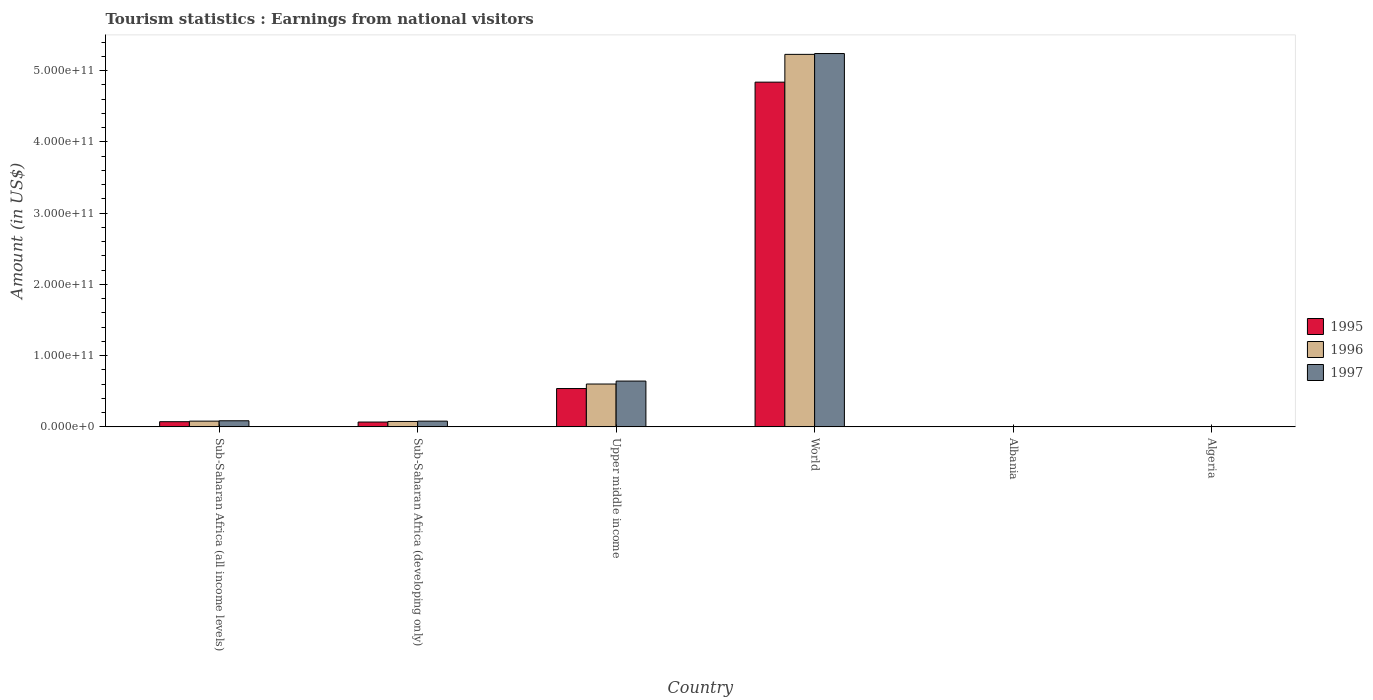How many groups of bars are there?
Provide a short and direct response. 6. Are the number of bars per tick equal to the number of legend labels?
Keep it short and to the point. Yes. Are the number of bars on each tick of the X-axis equal?
Offer a terse response. Yes. How many bars are there on the 2nd tick from the left?
Ensure brevity in your answer.  3. What is the label of the 5th group of bars from the left?
Provide a succinct answer. Albania. In how many cases, is the number of bars for a given country not equal to the number of legend labels?
Your response must be concise. 0. What is the earnings from national visitors in 1996 in Albania?
Your answer should be compact. 9.38e+07. Across all countries, what is the maximum earnings from national visitors in 1996?
Your response must be concise. 5.23e+11. Across all countries, what is the minimum earnings from national visitors in 1996?
Your answer should be compact. 4.50e+07. In which country was the earnings from national visitors in 1995 maximum?
Make the answer very short. World. In which country was the earnings from national visitors in 1995 minimum?
Your answer should be very brief. Algeria. What is the total earnings from national visitors in 1997 in the graph?
Make the answer very short. 6.05e+11. What is the difference between the earnings from national visitors in 1996 in Sub-Saharan Africa (developing only) and that in World?
Provide a short and direct response. -5.15e+11. What is the difference between the earnings from national visitors in 1995 in Algeria and the earnings from national visitors in 1997 in Sub-Saharan Africa (developing only)?
Provide a succinct answer. -8.02e+09. What is the average earnings from national visitors in 1997 per country?
Offer a very short reply. 1.01e+11. What is the difference between the earnings from national visitors of/in 1995 and earnings from national visitors of/in 1997 in Algeria?
Provide a succinct answer. 4.00e+06. In how many countries, is the earnings from national visitors in 1997 greater than 20000000000 US$?
Give a very brief answer. 2. What is the ratio of the earnings from national visitors in 1997 in Algeria to that in Sub-Saharan Africa (all income levels)?
Your response must be concise. 0. What is the difference between the highest and the second highest earnings from national visitors in 1996?
Provide a succinct answer. -4.63e+11. What is the difference between the highest and the lowest earnings from national visitors in 1997?
Provide a short and direct response. 5.24e+11. In how many countries, is the earnings from national visitors in 1995 greater than the average earnings from national visitors in 1995 taken over all countries?
Your answer should be compact. 1. Is it the case that in every country, the sum of the earnings from national visitors in 1997 and earnings from national visitors in 1995 is greater than the earnings from national visitors in 1996?
Provide a succinct answer. Yes. Are all the bars in the graph horizontal?
Keep it short and to the point. No. What is the difference between two consecutive major ticks on the Y-axis?
Your answer should be very brief. 1.00e+11. Are the values on the major ticks of Y-axis written in scientific E-notation?
Provide a short and direct response. Yes. Does the graph contain any zero values?
Ensure brevity in your answer.  No. Where does the legend appear in the graph?
Offer a terse response. Center right. What is the title of the graph?
Your answer should be compact. Tourism statistics : Earnings from national visitors. Does "1981" appear as one of the legend labels in the graph?
Your answer should be compact. No. What is the Amount (in US$) of 1995 in Sub-Saharan Africa (all income levels)?
Give a very brief answer. 7.27e+09. What is the Amount (in US$) of 1996 in Sub-Saharan Africa (all income levels)?
Offer a terse response. 8.05e+09. What is the Amount (in US$) in 1997 in Sub-Saharan Africa (all income levels)?
Offer a very short reply. 8.55e+09. What is the Amount (in US$) of 1995 in Sub-Saharan Africa (developing only)?
Your answer should be compact. 6.79e+09. What is the Amount (in US$) of 1996 in Sub-Saharan Africa (developing only)?
Provide a succinct answer. 7.59e+09. What is the Amount (in US$) of 1997 in Sub-Saharan Africa (developing only)?
Offer a terse response. 8.06e+09. What is the Amount (in US$) of 1995 in Upper middle income?
Your response must be concise. 5.38e+1. What is the Amount (in US$) of 1996 in Upper middle income?
Offer a very short reply. 6.01e+1. What is the Amount (in US$) of 1997 in Upper middle income?
Your answer should be compact. 6.43e+1. What is the Amount (in US$) in 1995 in World?
Offer a very short reply. 4.84e+11. What is the Amount (in US$) in 1996 in World?
Make the answer very short. 5.23e+11. What is the Amount (in US$) of 1997 in World?
Offer a very short reply. 5.24e+11. What is the Amount (in US$) in 1995 in Albania?
Give a very brief answer. 7.04e+07. What is the Amount (in US$) of 1996 in Albania?
Your response must be concise. 9.38e+07. What is the Amount (in US$) of 1997 in Albania?
Your response must be concise. 3.36e+07. What is the Amount (in US$) in 1995 in Algeria?
Offer a terse response. 3.20e+07. What is the Amount (in US$) in 1996 in Algeria?
Make the answer very short. 4.50e+07. What is the Amount (in US$) of 1997 in Algeria?
Ensure brevity in your answer.  2.80e+07. Across all countries, what is the maximum Amount (in US$) of 1995?
Keep it short and to the point. 4.84e+11. Across all countries, what is the maximum Amount (in US$) in 1996?
Provide a short and direct response. 5.23e+11. Across all countries, what is the maximum Amount (in US$) of 1997?
Offer a terse response. 5.24e+11. Across all countries, what is the minimum Amount (in US$) in 1995?
Ensure brevity in your answer.  3.20e+07. Across all countries, what is the minimum Amount (in US$) of 1996?
Provide a succinct answer. 4.50e+07. Across all countries, what is the minimum Amount (in US$) in 1997?
Keep it short and to the point. 2.80e+07. What is the total Amount (in US$) of 1995 in the graph?
Offer a terse response. 5.52e+11. What is the total Amount (in US$) in 1996 in the graph?
Ensure brevity in your answer.  5.99e+11. What is the total Amount (in US$) in 1997 in the graph?
Your answer should be very brief. 6.05e+11. What is the difference between the Amount (in US$) in 1995 in Sub-Saharan Africa (all income levels) and that in Sub-Saharan Africa (developing only)?
Keep it short and to the point. 4.77e+08. What is the difference between the Amount (in US$) of 1996 in Sub-Saharan Africa (all income levels) and that in Sub-Saharan Africa (developing only)?
Offer a very short reply. 4.63e+08. What is the difference between the Amount (in US$) in 1997 in Sub-Saharan Africa (all income levels) and that in Sub-Saharan Africa (developing only)?
Your response must be concise. 4.95e+08. What is the difference between the Amount (in US$) in 1995 in Sub-Saharan Africa (all income levels) and that in Upper middle income?
Your answer should be compact. -4.65e+1. What is the difference between the Amount (in US$) of 1996 in Sub-Saharan Africa (all income levels) and that in Upper middle income?
Provide a succinct answer. -5.21e+1. What is the difference between the Amount (in US$) in 1997 in Sub-Saharan Africa (all income levels) and that in Upper middle income?
Your answer should be compact. -5.57e+1. What is the difference between the Amount (in US$) in 1995 in Sub-Saharan Africa (all income levels) and that in World?
Provide a short and direct response. -4.76e+11. What is the difference between the Amount (in US$) of 1996 in Sub-Saharan Africa (all income levels) and that in World?
Offer a very short reply. -5.15e+11. What is the difference between the Amount (in US$) of 1997 in Sub-Saharan Africa (all income levels) and that in World?
Keep it short and to the point. -5.15e+11. What is the difference between the Amount (in US$) in 1995 in Sub-Saharan Africa (all income levels) and that in Albania?
Keep it short and to the point. 7.20e+09. What is the difference between the Amount (in US$) in 1996 in Sub-Saharan Africa (all income levels) and that in Albania?
Provide a short and direct response. 7.96e+09. What is the difference between the Amount (in US$) in 1997 in Sub-Saharan Africa (all income levels) and that in Albania?
Make the answer very short. 8.52e+09. What is the difference between the Amount (in US$) in 1995 in Sub-Saharan Africa (all income levels) and that in Algeria?
Your answer should be very brief. 7.24e+09. What is the difference between the Amount (in US$) in 1996 in Sub-Saharan Africa (all income levels) and that in Algeria?
Provide a short and direct response. 8.01e+09. What is the difference between the Amount (in US$) in 1997 in Sub-Saharan Africa (all income levels) and that in Algeria?
Offer a terse response. 8.52e+09. What is the difference between the Amount (in US$) in 1995 in Sub-Saharan Africa (developing only) and that in Upper middle income?
Provide a short and direct response. -4.70e+1. What is the difference between the Amount (in US$) of 1996 in Sub-Saharan Africa (developing only) and that in Upper middle income?
Provide a succinct answer. -5.25e+1. What is the difference between the Amount (in US$) in 1997 in Sub-Saharan Africa (developing only) and that in Upper middle income?
Offer a very short reply. -5.62e+1. What is the difference between the Amount (in US$) in 1995 in Sub-Saharan Africa (developing only) and that in World?
Your response must be concise. -4.77e+11. What is the difference between the Amount (in US$) in 1996 in Sub-Saharan Africa (developing only) and that in World?
Keep it short and to the point. -5.15e+11. What is the difference between the Amount (in US$) of 1997 in Sub-Saharan Africa (developing only) and that in World?
Give a very brief answer. -5.16e+11. What is the difference between the Amount (in US$) in 1995 in Sub-Saharan Africa (developing only) and that in Albania?
Give a very brief answer. 6.72e+09. What is the difference between the Amount (in US$) in 1996 in Sub-Saharan Africa (developing only) and that in Albania?
Make the answer very short. 7.50e+09. What is the difference between the Amount (in US$) of 1997 in Sub-Saharan Africa (developing only) and that in Albania?
Offer a very short reply. 8.02e+09. What is the difference between the Amount (in US$) in 1995 in Sub-Saharan Africa (developing only) and that in Algeria?
Offer a very short reply. 6.76e+09. What is the difference between the Amount (in US$) in 1996 in Sub-Saharan Africa (developing only) and that in Algeria?
Your response must be concise. 7.54e+09. What is the difference between the Amount (in US$) in 1997 in Sub-Saharan Africa (developing only) and that in Algeria?
Your answer should be compact. 8.03e+09. What is the difference between the Amount (in US$) in 1995 in Upper middle income and that in World?
Keep it short and to the point. -4.30e+11. What is the difference between the Amount (in US$) in 1996 in Upper middle income and that in World?
Provide a succinct answer. -4.63e+11. What is the difference between the Amount (in US$) in 1997 in Upper middle income and that in World?
Keep it short and to the point. -4.60e+11. What is the difference between the Amount (in US$) in 1995 in Upper middle income and that in Albania?
Your answer should be very brief. 5.37e+1. What is the difference between the Amount (in US$) of 1996 in Upper middle income and that in Albania?
Offer a terse response. 6.00e+1. What is the difference between the Amount (in US$) in 1997 in Upper middle income and that in Albania?
Your response must be concise. 6.42e+1. What is the difference between the Amount (in US$) of 1995 in Upper middle income and that in Algeria?
Provide a short and direct response. 5.38e+1. What is the difference between the Amount (in US$) of 1996 in Upper middle income and that in Algeria?
Offer a very short reply. 6.01e+1. What is the difference between the Amount (in US$) of 1997 in Upper middle income and that in Algeria?
Ensure brevity in your answer.  6.42e+1. What is the difference between the Amount (in US$) in 1995 in World and that in Albania?
Keep it short and to the point. 4.84e+11. What is the difference between the Amount (in US$) of 1996 in World and that in Albania?
Provide a succinct answer. 5.23e+11. What is the difference between the Amount (in US$) in 1997 in World and that in Albania?
Your answer should be compact. 5.24e+11. What is the difference between the Amount (in US$) in 1995 in World and that in Algeria?
Keep it short and to the point. 4.84e+11. What is the difference between the Amount (in US$) of 1996 in World and that in Algeria?
Make the answer very short. 5.23e+11. What is the difference between the Amount (in US$) of 1997 in World and that in Algeria?
Make the answer very short. 5.24e+11. What is the difference between the Amount (in US$) of 1995 in Albania and that in Algeria?
Your answer should be compact. 3.84e+07. What is the difference between the Amount (in US$) in 1996 in Albania and that in Algeria?
Your answer should be very brief. 4.88e+07. What is the difference between the Amount (in US$) in 1997 in Albania and that in Algeria?
Provide a succinct answer. 5.60e+06. What is the difference between the Amount (in US$) in 1995 in Sub-Saharan Africa (all income levels) and the Amount (in US$) in 1996 in Sub-Saharan Africa (developing only)?
Ensure brevity in your answer.  -3.21e+08. What is the difference between the Amount (in US$) of 1995 in Sub-Saharan Africa (all income levels) and the Amount (in US$) of 1997 in Sub-Saharan Africa (developing only)?
Ensure brevity in your answer.  -7.87e+08. What is the difference between the Amount (in US$) of 1996 in Sub-Saharan Africa (all income levels) and the Amount (in US$) of 1997 in Sub-Saharan Africa (developing only)?
Offer a terse response. -2.95e+06. What is the difference between the Amount (in US$) of 1995 in Sub-Saharan Africa (all income levels) and the Amount (in US$) of 1996 in Upper middle income?
Keep it short and to the point. -5.29e+1. What is the difference between the Amount (in US$) in 1995 in Sub-Saharan Africa (all income levels) and the Amount (in US$) in 1997 in Upper middle income?
Your answer should be very brief. -5.70e+1. What is the difference between the Amount (in US$) of 1996 in Sub-Saharan Africa (all income levels) and the Amount (in US$) of 1997 in Upper middle income?
Your response must be concise. -5.62e+1. What is the difference between the Amount (in US$) in 1995 in Sub-Saharan Africa (all income levels) and the Amount (in US$) in 1996 in World?
Offer a very short reply. -5.15e+11. What is the difference between the Amount (in US$) of 1995 in Sub-Saharan Africa (all income levels) and the Amount (in US$) of 1997 in World?
Provide a succinct answer. -5.17e+11. What is the difference between the Amount (in US$) in 1996 in Sub-Saharan Africa (all income levels) and the Amount (in US$) in 1997 in World?
Offer a terse response. -5.16e+11. What is the difference between the Amount (in US$) in 1995 in Sub-Saharan Africa (all income levels) and the Amount (in US$) in 1996 in Albania?
Give a very brief answer. 7.17e+09. What is the difference between the Amount (in US$) of 1995 in Sub-Saharan Africa (all income levels) and the Amount (in US$) of 1997 in Albania?
Offer a terse response. 7.24e+09. What is the difference between the Amount (in US$) of 1996 in Sub-Saharan Africa (all income levels) and the Amount (in US$) of 1997 in Albania?
Your response must be concise. 8.02e+09. What is the difference between the Amount (in US$) of 1995 in Sub-Saharan Africa (all income levels) and the Amount (in US$) of 1996 in Algeria?
Keep it short and to the point. 7.22e+09. What is the difference between the Amount (in US$) of 1995 in Sub-Saharan Africa (all income levels) and the Amount (in US$) of 1997 in Algeria?
Ensure brevity in your answer.  7.24e+09. What is the difference between the Amount (in US$) of 1996 in Sub-Saharan Africa (all income levels) and the Amount (in US$) of 1997 in Algeria?
Provide a short and direct response. 8.02e+09. What is the difference between the Amount (in US$) in 1995 in Sub-Saharan Africa (developing only) and the Amount (in US$) in 1996 in Upper middle income?
Your response must be concise. -5.33e+1. What is the difference between the Amount (in US$) in 1995 in Sub-Saharan Africa (developing only) and the Amount (in US$) in 1997 in Upper middle income?
Give a very brief answer. -5.75e+1. What is the difference between the Amount (in US$) in 1996 in Sub-Saharan Africa (developing only) and the Amount (in US$) in 1997 in Upper middle income?
Make the answer very short. -5.67e+1. What is the difference between the Amount (in US$) in 1995 in Sub-Saharan Africa (developing only) and the Amount (in US$) in 1996 in World?
Your response must be concise. -5.16e+11. What is the difference between the Amount (in US$) in 1995 in Sub-Saharan Africa (developing only) and the Amount (in US$) in 1997 in World?
Make the answer very short. -5.17e+11. What is the difference between the Amount (in US$) of 1996 in Sub-Saharan Africa (developing only) and the Amount (in US$) of 1997 in World?
Provide a short and direct response. -5.16e+11. What is the difference between the Amount (in US$) of 1995 in Sub-Saharan Africa (developing only) and the Amount (in US$) of 1996 in Albania?
Provide a short and direct response. 6.70e+09. What is the difference between the Amount (in US$) of 1995 in Sub-Saharan Africa (developing only) and the Amount (in US$) of 1997 in Albania?
Your response must be concise. 6.76e+09. What is the difference between the Amount (in US$) of 1996 in Sub-Saharan Africa (developing only) and the Amount (in US$) of 1997 in Albania?
Ensure brevity in your answer.  7.56e+09. What is the difference between the Amount (in US$) of 1995 in Sub-Saharan Africa (developing only) and the Amount (in US$) of 1996 in Algeria?
Your response must be concise. 6.75e+09. What is the difference between the Amount (in US$) of 1995 in Sub-Saharan Africa (developing only) and the Amount (in US$) of 1997 in Algeria?
Your response must be concise. 6.76e+09. What is the difference between the Amount (in US$) of 1996 in Sub-Saharan Africa (developing only) and the Amount (in US$) of 1997 in Algeria?
Give a very brief answer. 7.56e+09. What is the difference between the Amount (in US$) in 1995 in Upper middle income and the Amount (in US$) in 1996 in World?
Give a very brief answer. -4.69e+11. What is the difference between the Amount (in US$) in 1995 in Upper middle income and the Amount (in US$) in 1997 in World?
Make the answer very short. -4.70e+11. What is the difference between the Amount (in US$) of 1996 in Upper middle income and the Amount (in US$) of 1997 in World?
Give a very brief answer. -4.64e+11. What is the difference between the Amount (in US$) in 1995 in Upper middle income and the Amount (in US$) in 1996 in Albania?
Your answer should be compact. 5.37e+1. What is the difference between the Amount (in US$) of 1995 in Upper middle income and the Amount (in US$) of 1997 in Albania?
Give a very brief answer. 5.38e+1. What is the difference between the Amount (in US$) in 1996 in Upper middle income and the Amount (in US$) in 1997 in Albania?
Provide a succinct answer. 6.01e+1. What is the difference between the Amount (in US$) of 1995 in Upper middle income and the Amount (in US$) of 1996 in Algeria?
Your answer should be compact. 5.38e+1. What is the difference between the Amount (in US$) in 1995 in Upper middle income and the Amount (in US$) in 1997 in Algeria?
Provide a succinct answer. 5.38e+1. What is the difference between the Amount (in US$) in 1996 in Upper middle income and the Amount (in US$) in 1997 in Algeria?
Provide a succinct answer. 6.01e+1. What is the difference between the Amount (in US$) of 1995 in World and the Amount (in US$) of 1996 in Albania?
Offer a terse response. 4.84e+11. What is the difference between the Amount (in US$) in 1995 in World and the Amount (in US$) in 1997 in Albania?
Your response must be concise. 4.84e+11. What is the difference between the Amount (in US$) of 1996 in World and the Amount (in US$) of 1997 in Albania?
Provide a succinct answer. 5.23e+11. What is the difference between the Amount (in US$) of 1995 in World and the Amount (in US$) of 1996 in Algeria?
Your answer should be compact. 4.84e+11. What is the difference between the Amount (in US$) in 1995 in World and the Amount (in US$) in 1997 in Algeria?
Make the answer very short. 4.84e+11. What is the difference between the Amount (in US$) in 1996 in World and the Amount (in US$) in 1997 in Algeria?
Your answer should be very brief. 5.23e+11. What is the difference between the Amount (in US$) in 1995 in Albania and the Amount (in US$) in 1996 in Algeria?
Give a very brief answer. 2.54e+07. What is the difference between the Amount (in US$) in 1995 in Albania and the Amount (in US$) in 1997 in Algeria?
Provide a short and direct response. 4.24e+07. What is the difference between the Amount (in US$) of 1996 in Albania and the Amount (in US$) of 1997 in Algeria?
Make the answer very short. 6.58e+07. What is the average Amount (in US$) of 1995 per country?
Ensure brevity in your answer.  9.19e+1. What is the average Amount (in US$) of 1996 per country?
Give a very brief answer. 9.98e+1. What is the average Amount (in US$) of 1997 per country?
Your answer should be compact. 1.01e+11. What is the difference between the Amount (in US$) of 1995 and Amount (in US$) of 1996 in Sub-Saharan Africa (all income levels)?
Give a very brief answer. -7.84e+08. What is the difference between the Amount (in US$) of 1995 and Amount (in US$) of 1997 in Sub-Saharan Africa (all income levels)?
Offer a very short reply. -1.28e+09. What is the difference between the Amount (in US$) of 1996 and Amount (in US$) of 1997 in Sub-Saharan Africa (all income levels)?
Ensure brevity in your answer.  -4.98e+08. What is the difference between the Amount (in US$) of 1995 and Amount (in US$) of 1996 in Sub-Saharan Africa (developing only)?
Offer a terse response. -7.98e+08. What is the difference between the Amount (in US$) of 1995 and Amount (in US$) of 1997 in Sub-Saharan Africa (developing only)?
Offer a terse response. -1.26e+09. What is the difference between the Amount (in US$) of 1996 and Amount (in US$) of 1997 in Sub-Saharan Africa (developing only)?
Ensure brevity in your answer.  -4.66e+08. What is the difference between the Amount (in US$) of 1995 and Amount (in US$) of 1996 in Upper middle income?
Your response must be concise. -6.33e+09. What is the difference between the Amount (in US$) in 1995 and Amount (in US$) in 1997 in Upper middle income?
Make the answer very short. -1.05e+1. What is the difference between the Amount (in US$) in 1996 and Amount (in US$) in 1997 in Upper middle income?
Give a very brief answer. -4.15e+09. What is the difference between the Amount (in US$) in 1995 and Amount (in US$) in 1996 in World?
Give a very brief answer. -3.90e+1. What is the difference between the Amount (in US$) in 1995 and Amount (in US$) in 1997 in World?
Give a very brief answer. -4.01e+1. What is the difference between the Amount (in US$) in 1996 and Amount (in US$) in 1997 in World?
Offer a very short reply. -1.17e+09. What is the difference between the Amount (in US$) in 1995 and Amount (in US$) in 1996 in Albania?
Provide a succinct answer. -2.34e+07. What is the difference between the Amount (in US$) in 1995 and Amount (in US$) in 1997 in Albania?
Your answer should be very brief. 3.68e+07. What is the difference between the Amount (in US$) in 1996 and Amount (in US$) in 1997 in Albania?
Your response must be concise. 6.02e+07. What is the difference between the Amount (in US$) of 1995 and Amount (in US$) of 1996 in Algeria?
Keep it short and to the point. -1.30e+07. What is the difference between the Amount (in US$) in 1996 and Amount (in US$) in 1997 in Algeria?
Provide a succinct answer. 1.70e+07. What is the ratio of the Amount (in US$) of 1995 in Sub-Saharan Africa (all income levels) to that in Sub-Saharan Africa (developing only)?
Your response must be concise. 1.07. What is the ratio of the Amount (in US$) in 1996 in Sub-Saharan Africa (all income levels) to that in Sub-Saharan Africa (developing only)?
Your answer should be very brief. 1.06. What is the ratio of the Amount (in US$) in 1997 in Sub-Saharan Africa (all income levels) to that in Sub-Saharan Africa (developing only)?
Offer a very short reply. 1.06. What is the ratio of the Amount (in US$) in 1995 in Sub-Saharan Africa (all income levels) to that in Upper middle income?
Offer a very short reply. 0.14. What is the ratio of the Amount (in US$) of 1996 in Sub-Saharan Africa (all income levels) to that in Upper middle income?
Your answer should be very brief. 0.13. What is the ratio of the Amount (in US$) in 1997 in Sub-Saharan Africa (all income levels) to that in Upper middle income?
Keep it short and to the point. 0.13. What is the ratio of the Amount (in US$) of 1995 in Sub-Saharan Africa (all income levels) to that in World?
Give a very brief answer. 0.01. What is the ratio of the Amount (in US$) of 1996 in Sub-Saharan Africa (all income levels) to that in World?
Your answer should be compact. 0.02. What is the ratio of the Amount (in US$) in 1997 in Sub-Saharan Africa (all income levels) to that in World?
Provide a succinct answer. 0.02. What is the ratio of the Amount (in US$) of 1995 in Sub-Saharan Africa (all income levels) to that in Albania?
Ensure brevity in your answer.  103.25. What is the ratio of the Amount (in US$) of 1996 in Sub-Saharan Africa (all income levels) to that in Albania?
Offer a very short reply. 85.85. What is the ratio of the Amount (in US$) of 1997 in Sub-Saharan Africa (all income levels) to that in Albania?
Keep it short and to the point. 254.48. What is the ratio of the Amount (in US$) in 1995 in Sub-Saharan Africa (all income levels) to that in Algeria?
Your response must be concise. 227.15. What is the ratio of the Amount (in US$) of 1996 in Sub-Saharan Africa (all income levels) to that in Algeria?
Keep it short and to the point. 178.95. What is the ratio of the Amount (in US$) in 1997 in Sub-Saharan Africa (all income levels) to that in Algeria?
Keep it short and to the point. 305.37. What is the ratio of the Amount (in US$) of 1995 in Sub-Saharan Africa (developing only) to that in Upper middle income?
Offer a terse response. 0.13. What is the ratio of the Amount (in US$) of 1996 in Sub-Saharan Africa (developing only) to that in Upper middle income?
Make the answer very short. 0.13. What is the ratio of the Amount (in US$) of 1997 in Sub-Saharan Africa (developing only) to that in Upper middle income?
Provide a succinct answer. 0.13. What is the ratio of the Amount (in US$) in 1995 in Sub-Saharan Africa (developing only) to that in World?
Your answer should be compact. 0.01. What is the ratio of the Amount (in US$) of 1996 in Sub-Saharan Africa (developing only) to that in World?
Your answer should be compact. 0.01. What is the ratio of the Amount (in US$) of 1997 in Sub-Saharan Africa (developing only) to that in World?
Keep it short and to the point. 0.02. What is the ratio of the Amount (in US$) in 1995 in Sub-Saharan Africa (developing only) to that in Albania?
Provide a short and direct response. 96.47. What is the ratio of the Amount (in US$) of 1996 in Sub-Saharan Africa (developing only) to that in Albania?
Provide a short and direct response. 80.91. What is the ratio of the Amount (in US$) in 1997 in Sub-Saharan Africa (developing only) to that in Albania?
Your answer should be very brief. 239.76. What is the ratio of the Amount (in US$) in 1995 in Sub-Saharan Africa (developing only) to that in Algeria?
Ensure brevity in your answer.  212.23. What is the ratio of the Amount (in US$) of 1996 in Sub-Saharan Africa (developing only) to that in Algeria?
Keep it short and to the point. 168.65. What is the ratio of the Amount (in US$) in 1997 in Sub-Saharan Africa (developing only) to that in Algeria?
Ensure brevity in your answer.  287.71. What is the ratio of the Amount (in US$) in 1995 in Upper middle income to that in World?
Make the answer very short. 0.11. What is the ratio of the Amount (in US$) of 1996 in Upper middle income to that in World?
Provide a short and direct response. 0.12. What is the ratio of the Amount (in US$) in 1997 in Upper middle income to that in World?
Give a very brief answer. 0.12. What is the ratio of the Amount (in US$) in 1995 in Upper middle income to that in Albania?
Your answer should be compact. 764.16. What is the ratio of the Amount (in US$) in 1996 in Upper middle income to that in Albania?
Make the answer very short. 641.02. What is the ratio of the Amount (in US$) in 1997 in Upper middle income to that in Albania?
Keep it short and to the point. 1912.87. What is the ratio of the Amount (in US$) of 1995 in Upper middle income to that in Algeria?
Keep it short and to the point. 1681.15. What is the ratio of the Amount (in US$) of 1996 in Upper middle income to that in Algeria?
Give a very brief answer. 1336.17. What is the ratio of the Amount (in US$) in 1997 in Upper middle income to that in Algeria?
Offer a terse response. 2295.45. What is the ratio of the Amount (in US$) in 1995 in World to that in Albania?
Give a very brief answer. 6871.01. What is the ratio of the Amount (in US$) of 1996 in World to that in Albania?
Offer a very short reply. 5572.3. What is the ratio of the Amount (in US$) of 1997 in World to that in Albania?
Your answer should be compact. 1.56e+04. What is the ratio of the Amount (in US$) of 1995 in World to that in Algeria?
Keep it short and to the point. 1.51e+04. What is the ratio of the Amount (in US$) in 1996 in World to that in Algeria?
Provide a short and direct response. 1.16e+04. What is the ratio of the Amount (in US$) in 1997 in World to that in Algeria?
Your answer should be compact. 1.87e+04. What is the ratio of the Amount (in US$) in 1996 in Albania to that in Algeria?
Offer a terse response. 2.08. What is the ratio of the Amount (in US$) of 1997 in Albania to that in Algeria?
Your answer should be very brief. 1.2. What is the difference between the highest and the second highest Amount (in US$) of 1995?
Make the answer very short. 4.30e+11. What is the difference between the highest and the second highest Amount (in US$) in 1996?
Provide a short and direct response. 4.63e+11. What is the difference between the highest and the second highest Amount (in US$) in 1997?
Provide a succinct answer. 4.60e+11. What is the difference between the highest and the lowest Amount (in US$) of 1995?
Your answer should be compact. 4.84e+11. What is the difference between the highest and the lowest Amount (in US$) of 1996?
Your response must be concise. 5.23e+11. What is the difference between the highest and the lowest Amount (in US$) in 1997?
Your answer should be very brief. 5.24e+11. 